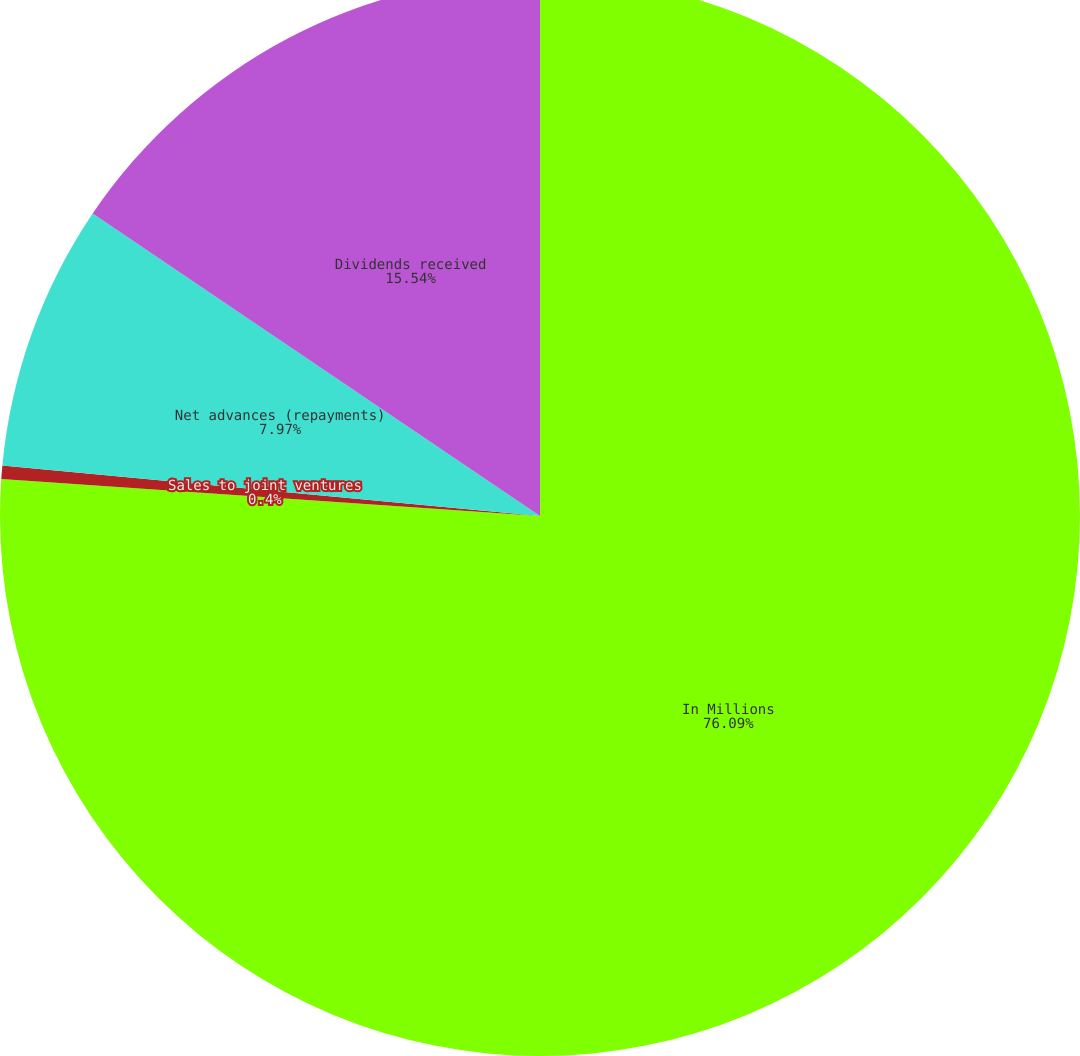<chart> <loc_0><loc_0><loc_500><loc_500><pie_chart><fcel>In Millions<fcel>Sales to joint ventures<fcel>Net advances (repayments)<fcel>Dividends received<nl><fcel>76.1%<fcel>0.4%<fcel>7.97%<fcel>15.54%<nl></chart> 